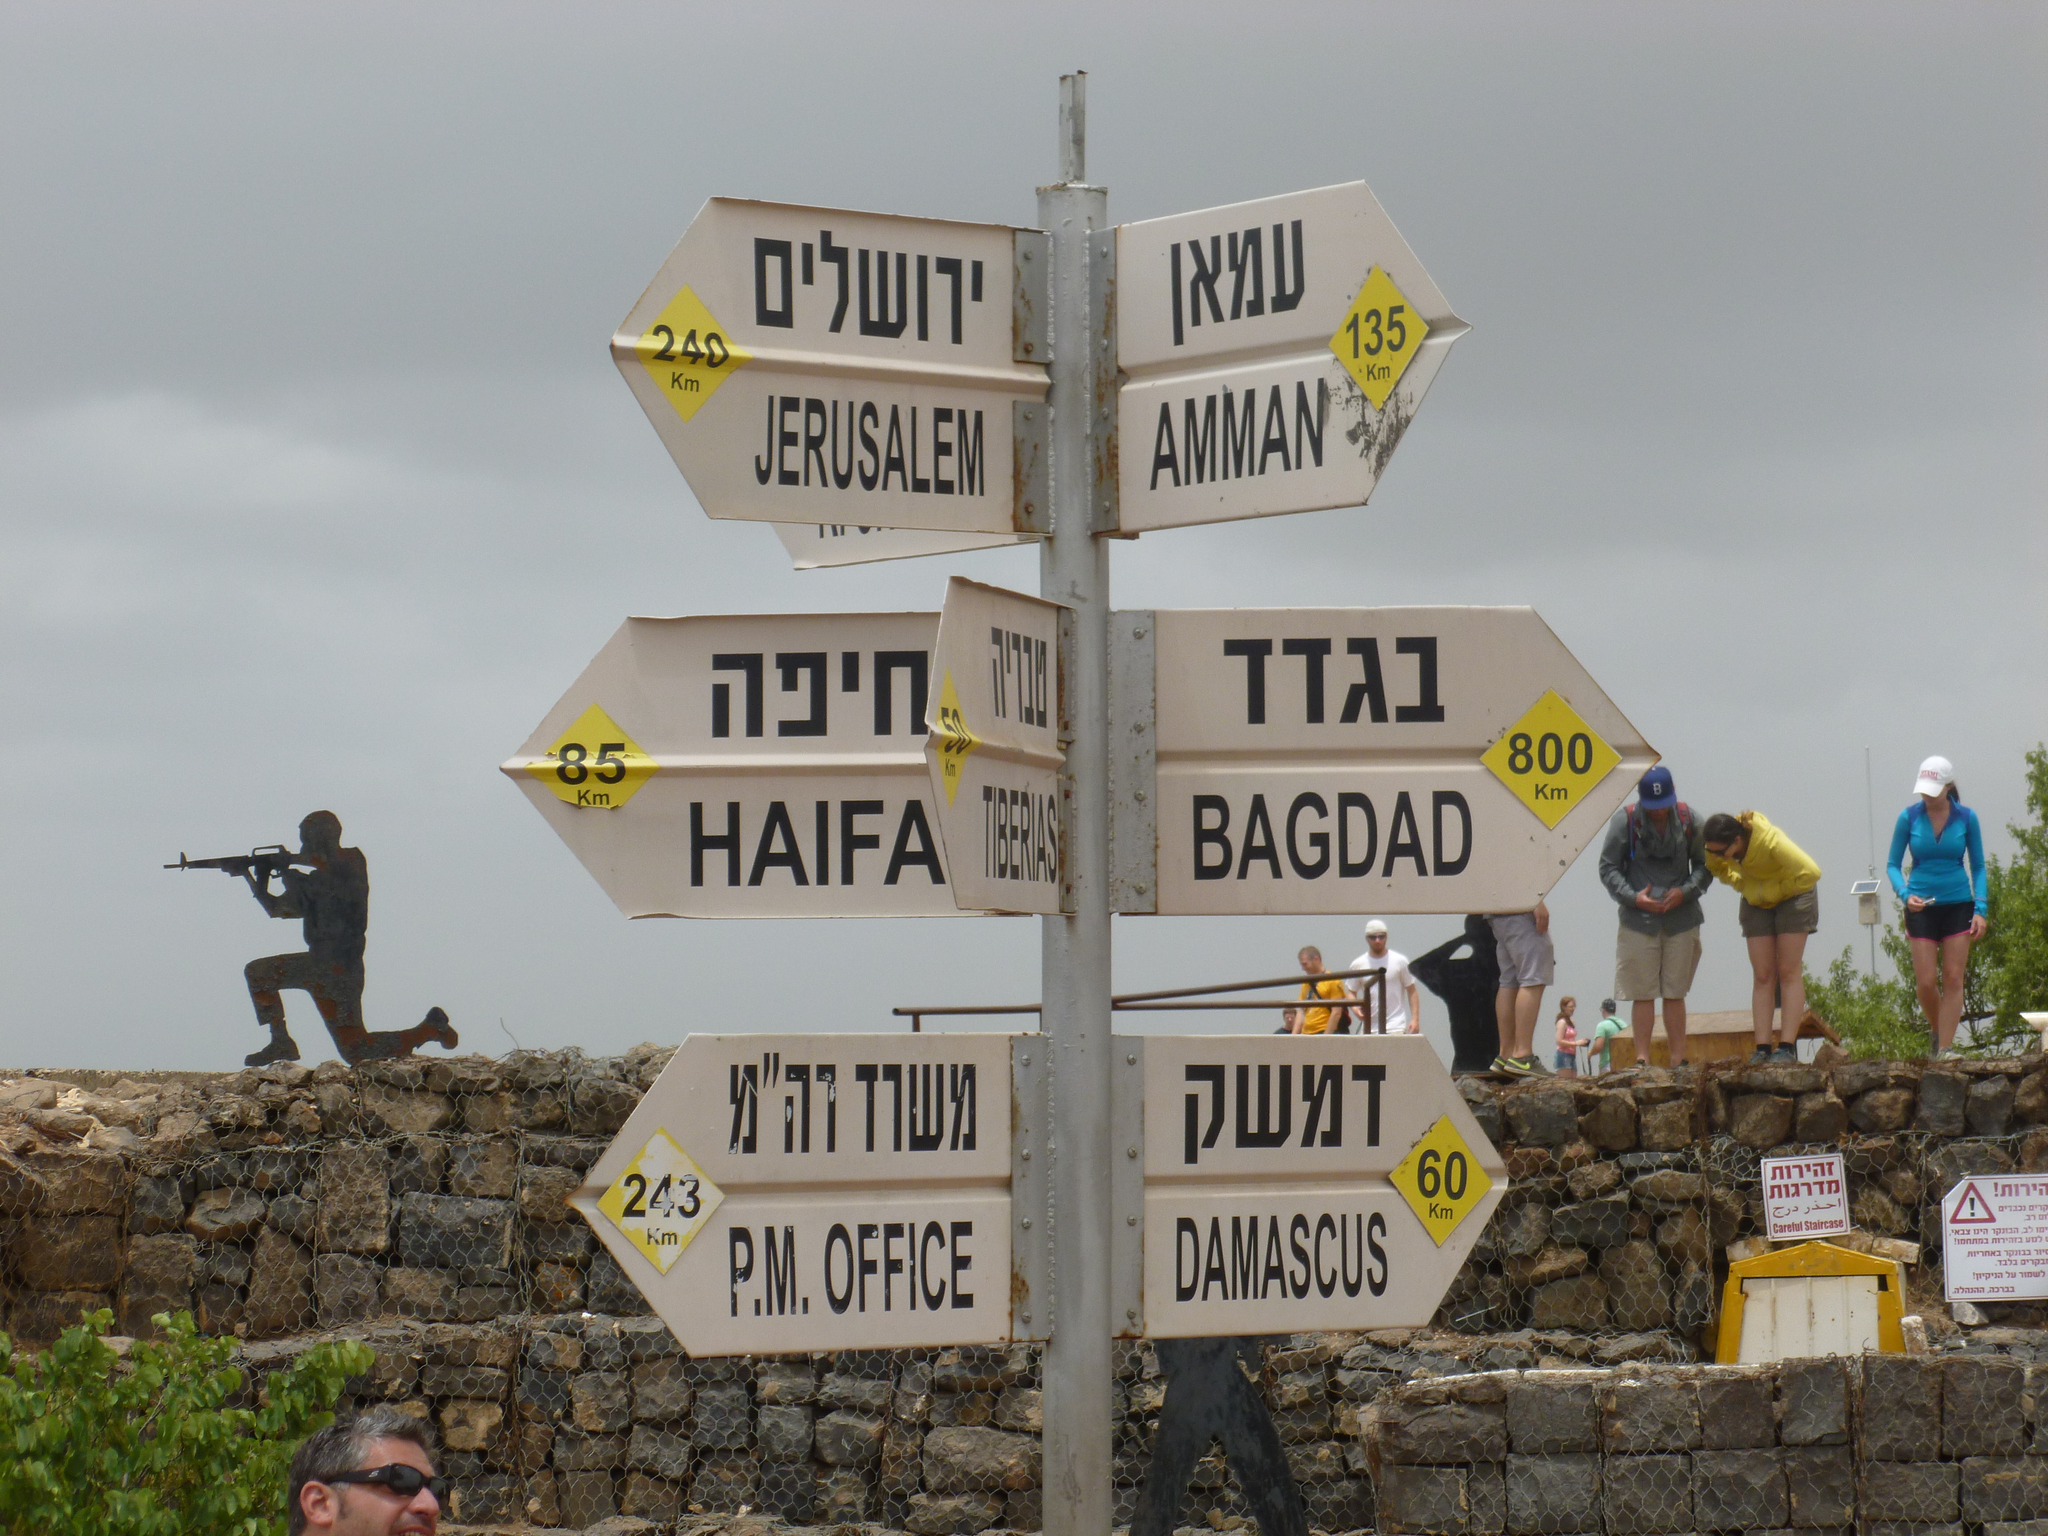Can you describe this image briefly? There is a pole with many sign boards. There are many people. Some are wearing caps. There are brick walls. And a person is wearing goggles. In the back there is sky. On the right side there are trees. Also there are sign boards. On the left side there is a person holding gun is on the wall. 